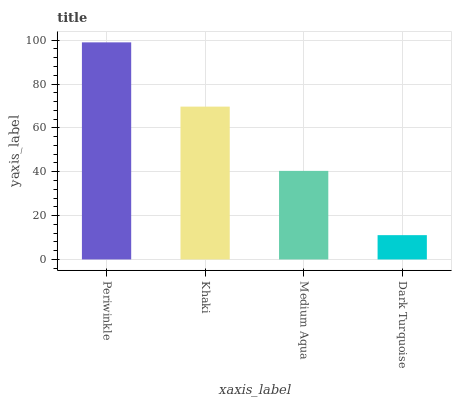Is Dark Turquoise the minimum?
Answer yes or no. Yes. Is Periwinkle the maximum?
Answer yes or no. Yes. Is Khaki the minimum?
Answer yes or no. No. Is Khaki the maximum?
Answer yes or no. No. Is Periwinkle greater than Khaki?
Answer yes or no. Yes. Is Khaki less than Periwinkle?
Answer yes or no. Yes. Is Khaki greater than Periwinkle?
Answer yes or no. No. Is Periwinkle less than Khaki?
Answer yes or no. No. Is Khaki the high median?
Answer yes or no. Yes. Is Medium Aqua the low median?
Answer yes or no. Yes. Is Dark Turquoise the high median?
Answer yes or no. No. Is Dark Turquoise the low median?
Answer yes or no. No. 